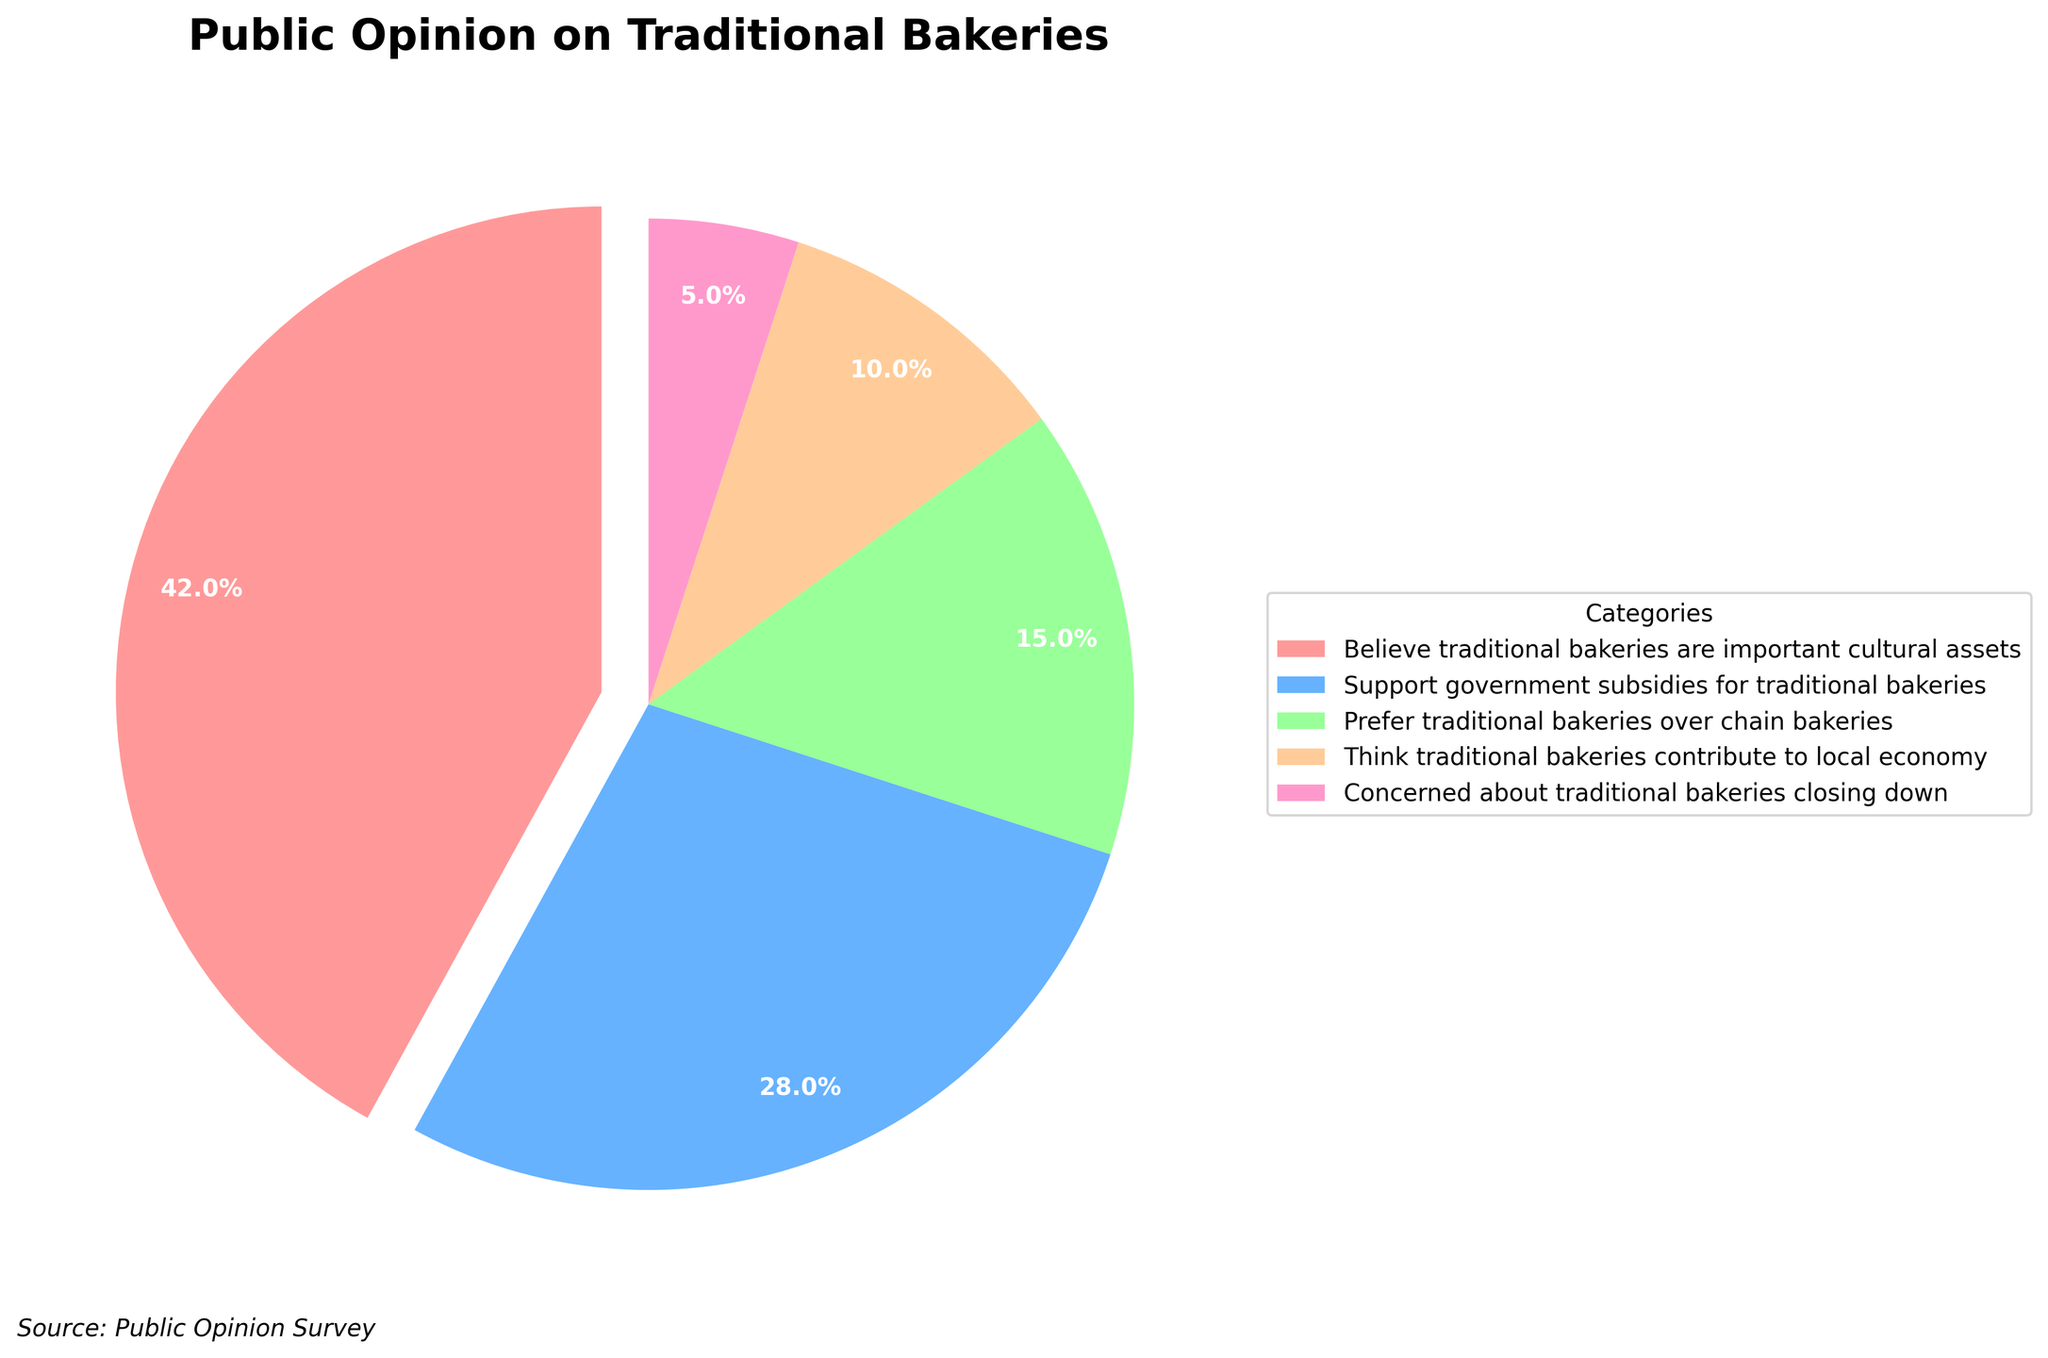What percentage of people believe traditional bakeries are important cultural assets? The largest wedge in the pie chart is labeled "Believe traditional bakeries are important cultural assets" and shows a percentage figure.
Answer: 42% How many more percentage points prioritize traditional bakeries as cultural assets over supporting government subsidies? To find the difference, subtract the percentage for supporting government subsidies (28%) from the percentage for cultural asset belief (42%). 42% - 28% = 14 percentage points.
Answer: 14 percentage points Which category has the smallest percentage in the pie chart? The smallest wedge in the pie chart represents the category "Concerned about traditional bakeries closing down", which is labeled with a 5% share.
Answer: Concerned about traditional bakeries closing down If we combine the percentages of those who prefer traditional bakeries over chain bakeries and those who think they contribute to the local economy, what percentage do we get? Add the percentage for the preference for traditional bakeries (15%) and the contribution to the local economy (10%). 15% + 10% = 25%.
Answer: 25% Which value is greater: the percentage of people who think traditional bakeries are important cultural assets or the combined percentage of the other categories? The combined percentage of the other categories is (28% + 15% + 10% + 5%) = 58%. Compare this with the 42% for cultural asset belief; 58% is greater.
Answer: Combined percentage of other categories What is the average percentage of the four smallest categories? The percentages for the four smallest categories are 28%, 15%, 10%, and 5%. First sum these values (28% + 15% + 10% + 5% = 58%), then divide by 4. The average is 58% / 4 = 14.5%.
Answer: 14.5% What proportion of the pie chart is focused on supporting government subsidies for traditional bakeries compared to those concerned about their closures? The percentage for supporting government subsidies is 28%, while concern for closures is 5%. To find the ratio, divide 28 by 5, which equals 5.6.
Answer: 5.6 Three categories combined: belief in cultural assets, support for subsidies, and preference over chain bakeries. What is the sum of their percentages? Add the percentages for cultural assets (42%), subsidies (28%), and preference over chain bakeries (15%). The sum is 42% + 28% + 15% = 85%.
Answer: 85% Which color represents the smallest segment of the pie chart? The smallest segment represents "Concerned about traditional bakeries closing down," which is colored in pink.
Answer: Pink 